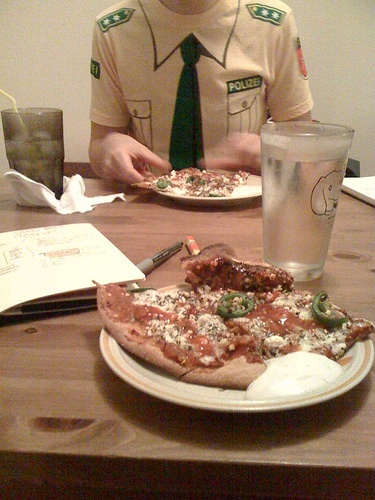Describe the objects in this image and their specific colors. I can see dining table in tan, gray, beige, and black tones, people in tan, gray, and black tones, pizza in tan, brown, and maroon tones, cup in tan and gray tones, and book in tan, beige, black, and maroon tones in this image. 